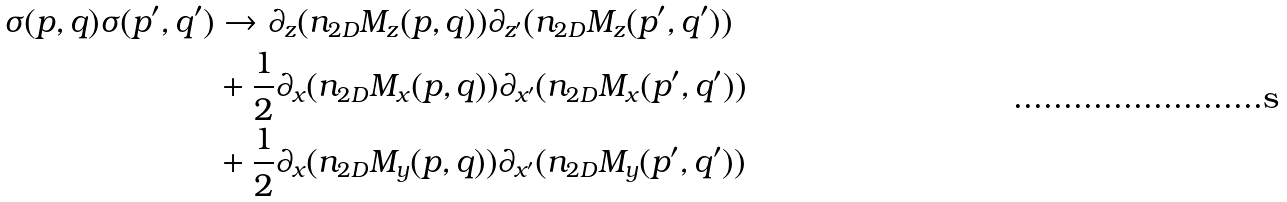Convert formula to latex. <formula><loc_0><loc_0><loc_500><loc_500>\sigma ( p , q ) \sigma ( p ^ { \prime } , q ^ { \prime } ) & \rightarrow \partial _ { z } ( n _ { 2 D } M _ { z } ( p , q ) ) \partial _ { z ^ { \prime } } ( n _ { 2 D } M _ { z } ( p ^ { \prime } , q ^ { \prime } ) ) \\ & + \frac { 1 } { 2 } \partial _ { x } ( n _ { 2 D } M _ { x } ( p , q ) ) \partial _ { x ^ { \prime } } ( n _ { 2 D } M _ { x } ( p ^ { \prime } , q ^ { \prime } ) ) \\ & + \frac { 1 } { 2 } \partial _ { x } ( n _ { 2 D } M _ { y } ( p , q ) ) \partial _ { x ^ { \prime } } ( n _ { 2 D } M _ { y } ( p ^ { \prime } , q ^ { \prime } ) )</formula> 